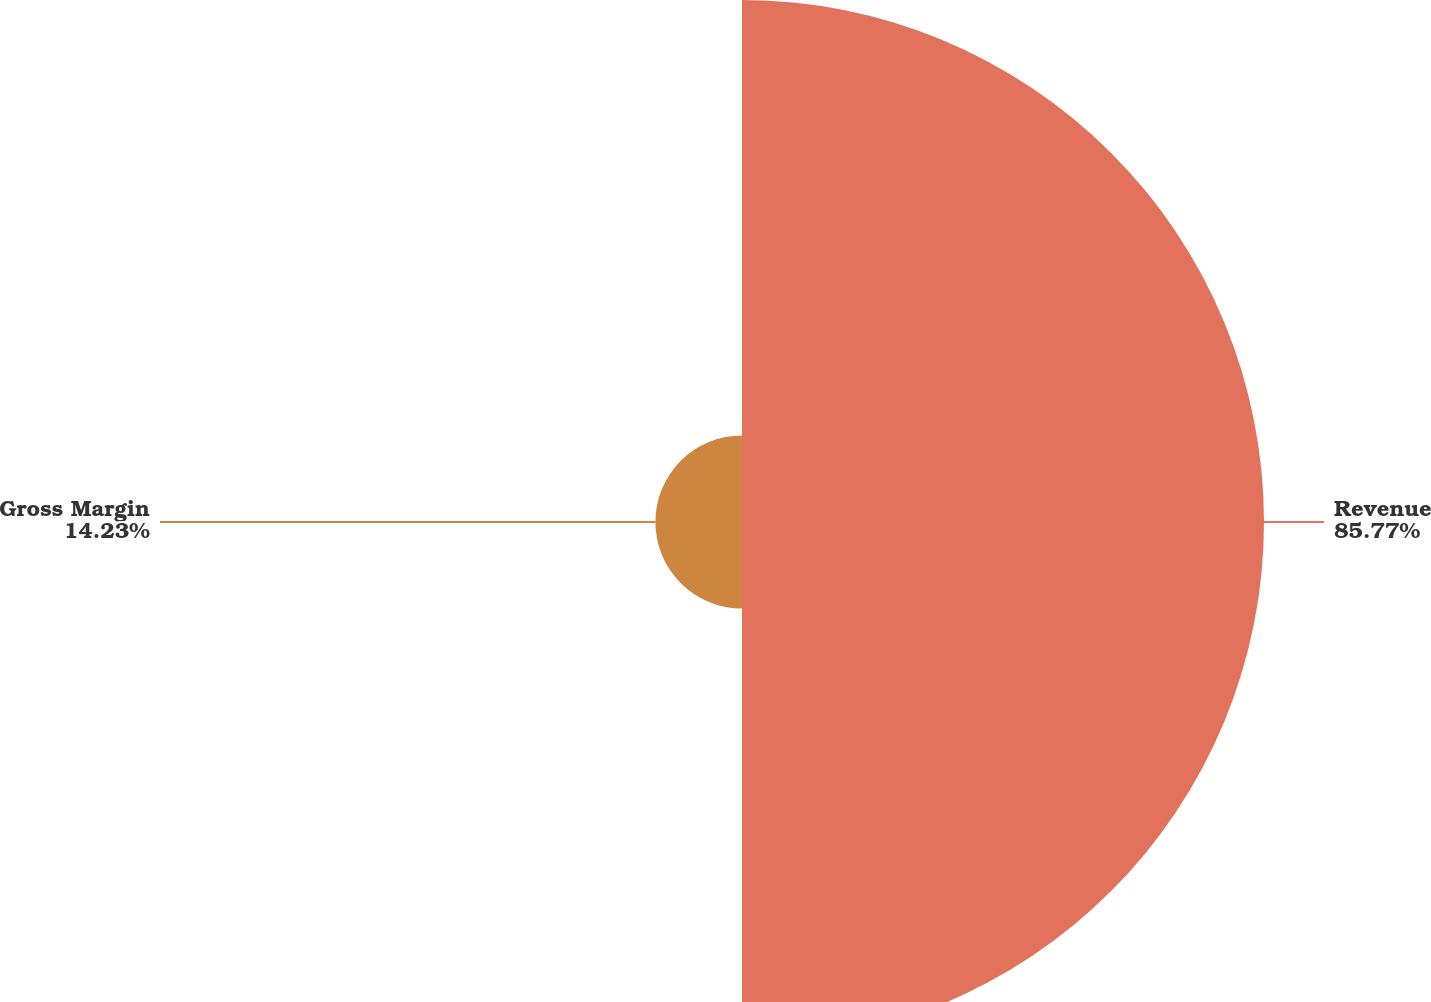Convert chart to OTSL. <chart><loc_0><loc_0><loc_500><loc_500><pie_chart><fcel>Revenue<fcel>Gross Margin<nl><fcel>85.77%<fcel>14.23%<nl></chart> 